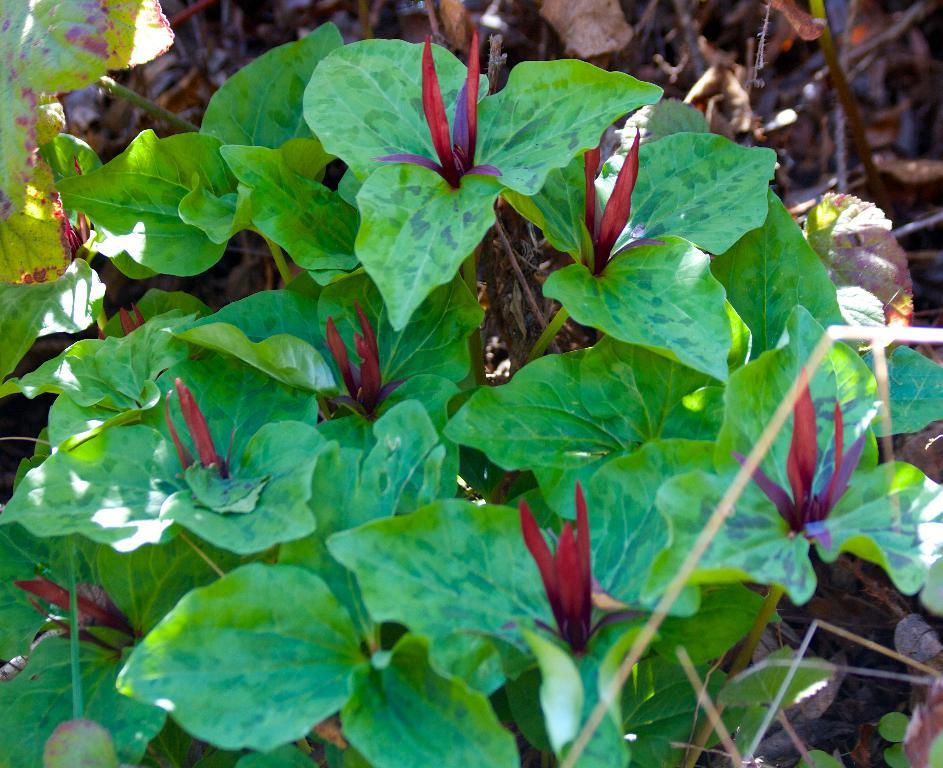What is present in the image? There is a plant in the image. What can be observed about the plant's leaves? The plant has green leaves. What type of nut is being used as a punishment in the image? There is no nut or punishment present in the image; it features a plant with green leaves. What kind of carriage can be seen in the image? There is no carriage present in the image; it features a plant with green leaves. 